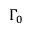<formula> <loc_0><loc_0><loc_500><loc_500>\Gamma _ { 0 }</formula> 